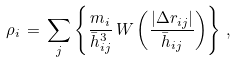Convert formula to latex. <formula><loc_0><loc_0><loc_500><loc_500>\rho _ { i } \, = \, \sum _ { j } \left \{ \frac { m _ { i } } { \bar { h } _ { i j } ^ { 3 } } \, W \left ( \frac { | \Delta { r } _ { i j } | } { \bar { h } _ { i j } } \right ) \right \} \, ,</formula> 